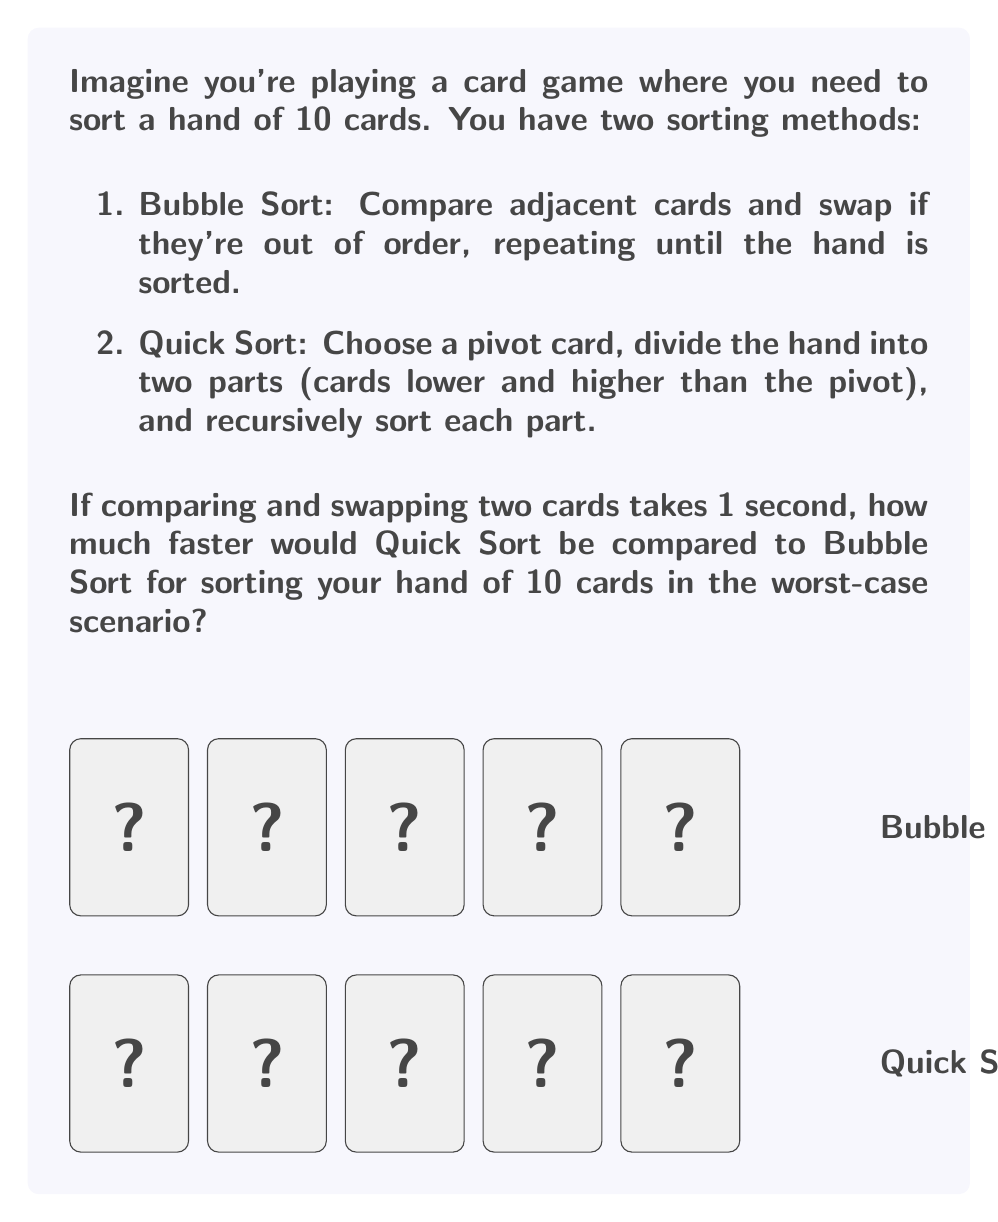Give your solution to this math problem. Let's break this down step-by-step:

1) First, let's recall the time complexities of these sorting algorithms:
   - Bubble Sort: $O(n^2)$ in the worst case
   - Quick Sort: $O(n \log n)$ in the average case, but $O(n^2)$ in the worst case

2) For Bubble Sort:
   - In the worst case (reverse sorted), it needs to make $n-1$ passes over the array, each pass comparing $n-1, n-2, ..., 1$ pairs.
   - Total comparisons = $\frac{n(n-1)}{2}$
   - For $n = 10$, that's $\frac{10 * 9}{2} = 45$ comparisons

3) For Quick Sort:
   - The worst case for Quick Sort occurs when the pivot is always the smallest or largest element.
   - In this case, it makes $n-1$ comparisons for the first partition, then $n-2$ for the next, and so on.
   - Total comparisons = $\frac{n(n-1)}{2}$
   - For $n = 10$, that's also $\frac{10 * 9}{2} = 45$ comparisons

4) Both algorithms make the same number of comparisons in their worst cases for this small input size.

5) However, Quick Sort is generally faster in practice due to better cache performance and the fact that its average case is much better than its worst case.

6) Since both algorithms make 45 comparisons in the worst case, and each comparison takes 1 second:
   - Bubble Sort time = 45 seconds
   - Quick Sort time = 45 seconds

7) The speed difference: 45 - 45 = 0 seconds

Therefore, for this small input size of 10 cards, there is no difference in speed between Bubble Sort and Quick Sort in the worst-case scenario.
Answer: 0 seconds 